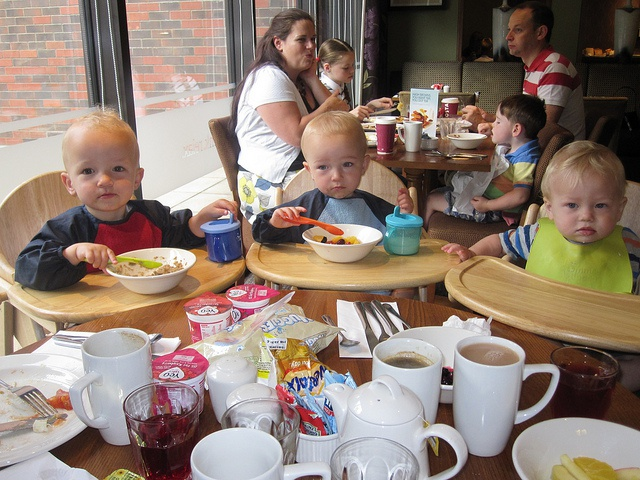Describe the objects in this image and their specific colors. I can see dining table in tan, lightgray, darkgray, black, and maroon tones, people in tan, black, brown, gray, and maroon tones, people in tan, olive, gray, and maroon tones, people in tan, white, gray, and lightpink tones, and chair in tan and olive tones in this image. 